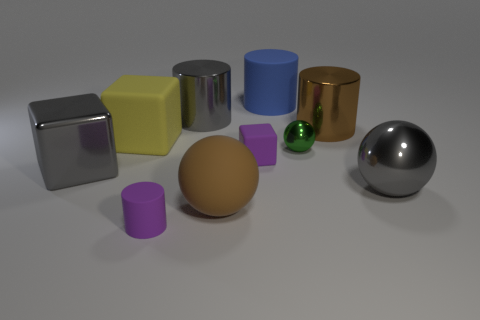Subtract all cubes. How many objects are left? 7 Add 7 tiny blocks. How many tiny blocks exist? 8 Subtract 0 red balls. How many objects are left? 10 Subtract all large balls. Subtract all brown spheres. How many objects are left? 7 Add 3 large rubber balls. How many large rubber balls are left? 4 